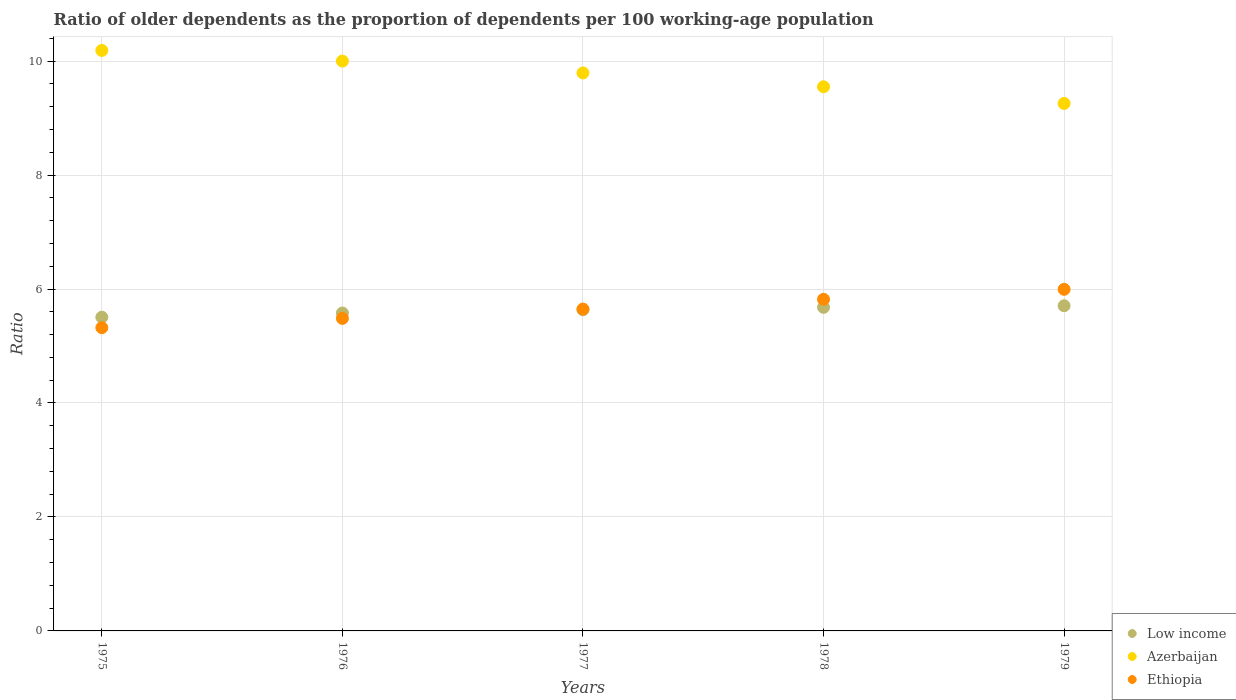How many different coloured dotlines are there?
Keep it short and to the point. 3. What is the age dependency ratio(old) in Azerbaijan in 1978?
Your answer should be very brief. 9.55. Across all years, what is the maximum age dependency ratio(old) in Ethiopia?
Make the answer very short. 5.99. Across all years, what is the minimum age dependency ratio(old) in Azerbaijan?
Keep it short and to the point. 9.26. In which year was the age dependency ratio(old) in Low income maximum?
Keep it short and to the point. 1979. In which year was the age dependency ratio(old) in Ethiopia minimum?
Your response must be concise. 1975. What is the total age dependency ratio(old) in Azerbaijan in the graph?
Make the answer very short. 48.78. What is the difference between the age dependency ratio(old) in Low income in 1975 and that in 1979?
Make the answer very short. -0.2. What is the difference between the age dependency ratio(old) in Ethiopia in 1979 and the age dependency ratio(old) in Azerbaijan in 1978?
Ensure brevity in your answer.  -3.55. What is the average age dependency ratio(old) in Low income per year?
Ensure brevity in your answer.  5.62. In the year 1977, what is the difference between the age dependency ratio(old) in Ethiopia and age dependency ratio(old) in Low income?
Provide a succinct answer. 0.01. In how many years, is the age dependency ratio(old) in Ethiopia greater than 4?
Offer a very short reply. 5. What is the ratio of the age dependency ratio(old) in Ethiopia in 1976 to that in 1979?
Your answer should be compact. 0.91. Is the age dependency ratio(old) in Ethiopia in 1976 less than that in 1979?
Your answer should be compact. Yes. Is the difference between the age dependency ratio(old) in Ethiopia in 1978 and 1979 greater than the difference between the age dependency ratio(old) in Low income in 1978 and 1979?
Provide a succinct answer. No. What is the difference between the highest and the second highest age dependency ratio(old) in Azerbaijan?
Your answer should be very brief. 0.19. What is the difference between the highest and the lowest age dependency ratio(old) in Ethiopia?
Make the answer very short. 0.67. Is the sum of the age dependency ratio(old) in Ethiopia in 1976 and 1978 greater than the maximum age dependency ratio(old) in Azerbaijan across all years?
Provide a succinct answer. Yes. Does the age dependency ratio(old) in Ethiopia monotonically increase over the years?
Ensure brevity in your answer.  Yes. Is the age dependency ratio(old) in Azerbaijan strictly greater than the age dependency ratio(old) in Ethiopia over the years?
Ensure brevity in your answer.  Yes. Is the age dependency ratio(old) in Low income strictly less than the age dependency ratio(old) in Ethiopia over the years?
Your answer should be very brief. No. How many years are there in the graph?
Keep it short and to the point. 5. How many legend labels are there?
Your answer should be very brief. 3. How are the legend labels stacked?
Your answer should be very brief. Vertical. What is the title of the graph?
Offer a terse response. Ratio of older dependents as the proportion of dependents per 100 working-age population. What is the label or title of the X-axis?
Offer a very short reply. Years. What is the label or title of the Y-axis?
Your answer should be very brief. Ratio. What is the Ratio of Low income in 1975?
Make the answer very short. 5.51. What is the Ratio in Azerbaijan in 1975?
Give a very brief answer. 10.19. What is the Ratio in Ethiopia in 1975?
Provide a succinct answer. 5.32. What is the Ratio of Low income in 1976?
Offer a very short reply. 5.58. What is the Ratio in Azerbaijan in 1976?
Your answer should be compact. 10. What is the Ratio in Ethiopia in 1976?
Your response must be concise. 5.48. What is the Ratio of Low income in 1977?
Offer a terse response. 5.64. What is the Ratio in Azerbaijan in 1977?
Your response must be concise. 9.79. What is the Ratio of Ethiopia in 1977?
Your answer should be very brief. 5.65. What is the Ratio of Low income in 1978?
Your response must be concise. 5.68. What is the Ratio in Azerbaijan in 1978?
Make the answer very short. 9.55. What is the Ratio in Ethiopia in 1978?
Keep it short and to the point. 5.82. What is the Ratio in Low income in 1979?
Offer a very short reply. 5.71. What is the Ratio of Azerbaijan in 1979?
Give a very brief answer. 9.26. What is the Ratio of Ethiopia in 1979?
Your answer should be very brief. 5.99. Across all years, what is the maximum Ratio in Low income?
Make the answer very short. 5.71. Across all years, what is the maximum Ratio in Azerbaijan?
Your response must be concise. 10.19. Across all years, what is the maximum Ratio of Ethiopia?
Offer a terse response. 5.99. Across all years, what is the minimum Ratio in Low income?
Your answer should be very brief. 5.51. Across all years, what is the minimum Ratio in Azerbaijan?
Ensure brevity in your answer.  9.26. Across all years, what is the minimum Ratio in Ethiopia?
Your answer should be very brief. 5.32. What is the total Ratio in Low income in the graph?
Give a very brief answer. 28.1. What is the total Ratio of Azerbaijan in the graph?
Provide a short and direct response. 48.78. What is the total Ratio of Ethiopia in the graph?
Your answer should be very brief. 28.27. What is the difference between the Ratio in Low income in 1975 and that in 1976?
Make the answer very short. -0.07. What is the difference between the Ratio in Azerbaijan in 1975 and that in 1976?
Keep it short and to the point. 0.19. What is the difference between the Ratio in Ethiopia in 1975 and that in 1976?
Ensure brevity in your answer.  -0.16. What is the difference between the Ratio in Low income in 1975 and that in 1977?
Make the answer very short. -0.13. What is the difference between the Ratio in Azerbaijan in 1975 and that in 1977?
Make the answer very short. 0.39. What is the difference between the Ratio of Ethiopia in 1975 and that in 1977?
Your answer should be compact. -0.33. What is the difference between the Ratio in Low income in 1975 and that in 1978?
Offer a very short reply. -0.17. What is the difference between the Ratio of Azerbaijan in 1975 and that in 1978?
Keep it short and to the point. 0.64. What is the difference between the Ratio in Ethiopia in 1975 and that in 1978?
Keep it short and to the point. -0.5. What is the difference between the Ratio in Low income in 1975 and that in 1979?
Give a very brief answer. -0.2. What is the difference between the Ratio in Ethiopia in 1975 and that in 1979?
Offer a very short reply. -0.67. What is the difference between the Ratio in Low income in 1976 and that in 1977?
Your answer should be compact. -0.06. What is the difference between the Ratio in Azerbaijan in 1976 and that in 1977?
Offer a very short reply. 0.21. What is the difference between the Ratio of Ethiopia in 1976 and that in 1977?
Ensure brevity in your answer.  -0.16. What is the difference between the Ratio of Low income in 1976 and that in 1978?
Offer a very short reply. -0.1. What is the difference between the Ratio in Azerbaijan in 1976 and that in 1978?
Ensure brevity in your answer.  0.45. What is the difference between the Ratio in Ethiopia in 1976 and that in 1978?
Offer a terse response. -0.34. What is the difference between the Ratio in Low income in 1976 and that in 1979?
Your response must be concise. -0.13. What is the difference between the Ratio of Azerbaijan in 1976 and that in 1979?
Provide a succinct answer. 0.74. What is the difference between the Ratio of Ethiopia in 1976 and that in 1979?
Provide a short and direct response. -0.51. What is the difference between the Ratio in Low income in 1977 and that in 1978?
Offer a terse response. -0.04. What is the difference between the Ratio of Azerbaijan in 1977 and that in 1978?
Make the answer very short. 0.24. What is the difference between the Ratio of Ethiopia in 1977 and that in 1978?
Offer a terse response. -0.17. What is the difference between the Ratio in Low income in 1977 and that in 1979?
Provide a succinct answer. -0.07. What is the difference between the Ratio in Azerbaijan in 1977 and that in 1979?
Your answer should be compact. 0.54. What is the difference between the Ratio of Ethiopia in 1977 and that in 1979?
Make the answer very short. -0.35. What is the difference between the Ratio of Low income in 1978 and that in 1979?
Provide a short and direct response. -0.03. What is the difference between the Ratio of Azerbaijan in 1978 and that in 1979?
Your response must be concise. 0.29. What is the difference between the Ratio of Ethiopia in 1978 and that in 1979?
Give a very brief answer. -0.17. What is the difference between the Ratio in Low income in 1975 and the Ratio in Azerbaijan in 1976?
Offer a very short reply. -4.49. What is the difference between the Ratio of Low income in 1975 and the Ratio of Ethiopia in 1976?
Ensure brevity in your answer.  0.02. What is the difference between the Ratio of Azerbaijan in 1975 and the Ratio of Ethiopia in 1976?
Provide a succinct answer. 4.7. What is the difference between the Ratio of Low income in 1975 and the Ratio of Azerbaijan in 1977?
Offer a terse response. -4.29. What is the difference between the Ratio of Low income in 1975 and the Ratio of Ethiopia in 1977?
Provide a short and direct response. -0.14. What is the difference between the Ratio in Azerbaijan in 1975 and the Ratio in Ethiopia in 1977?
Ensure brevity in your answer.  4.54. What is the difference between the Ratio of Low income in 1975 and the Ratio of Azerbaijan in 1978?
Offer a terse response. -4.04. What is the difference between the Ratio in Low income in 1975 and the Ratio in Ethiopia in 1978?
Give a very brief answer. -0.31. What is the difference between the Ratio of Azerbaijan in 1975 and the Ratio of Ethiopia in 1978?
Make the answer very short. 4.37. What is the difference between the Ratio in Low income in 1975 and the Ratio in Azerbaijan in 1979?
Ensure brevity in your answer.  -3.75. What is the difference between the Ratio in Low income in 1975 and the Ratio in Ethiopia in 1979?
Your answer should be very brief. -0.49. What is the difference between the Ratio in Azerbaijan in 1975 and the Ratio in Ethiopia in 1979?
Provide a short and direct response. 4.19. What is the difference between the Ratio in Low income in 1976 and the Ratio in Azerbaijan in 1977?
Make the answer very short. -4.21. What is the difference between the Ratio in Low income in 1976 and the Ratio in Ethiopia in 1977?
Keep it short and to the point. -0.07. What is the difference between the Ratio of Azerbaijan in 1976 and the Ratio of Ethiopia in 1977?
Keep it short and to the point. 4.35. What is the difference between the Ratio of Low income in 1976 and the Ratio of Azerbaijan in 1978?
Ensure brevity in your answer.  -3.97. What is the difference between the Ratio in Low income in 1976 and the Ratio in Ethiopia in 1978?
Your answer should be compact. -0.24. What is the difference between the Ratio of Azerbaijan in 1976 and the Ratio of Ethiopia in 1978?
Your answer should be very brief. 4.18. What is the difference between the Ratio in Low income in 1976 and the Ratio in Azerbaijan in 1979?
Ensure brevity in your answer.  -3.68. What is the difference between the Ratio in Low income in 1976 and the Ratio in Ethiopia in 1979?
Offer a very short reply. -0.42. What is the difference between the Ratio of Azerbaijan in 1976 and the Ratio of Ethiopia in 1979?
Your answer should be compact. 4.01. What is the difference between the Ratio of Low income in 1977 and the Ratio of Azerbaijan in 1978?
Your answer should be compact. -3.91. What is the difference between the Ratio in Low income in 1977 and the Ratio in Ethiopia in 1978?
Your answer should be compact. -0.18. What is the difference between the Ratio of Azerbaijan in 1977 and the Ratio of Ethiopia in 1978?
Provide a succinct answer. 3.97. What is the difference between the Ratio of Low income in 1977 and the Ratio of Azerbaijan in 1979?
Provide a short and direct response. -3.62. What is the difference between the Ratio in Low income in 1977 and the Ratio in Ethiopia in 1979?
Provide a succinct answer. -0.36. What is the difference between the Ratio in Azerbaijan in 1977 and the Ratio in Ethiopia in 1979?
Ensure brevity in your answer.  3.8. What is the difference between the Ratio in Low income in 1978 and the Ratio in Azerbaijan in 1979?
Offer a terse response. -3.58. What is the difference between the Ratio in Low income in 1978 and the Ratio in Ethiopia in 1979?
Offer a terse response. -0.32. What is the difference between the Ratio of Azerbaijan in 1978 and the Ratio of Ethiopia in 1979?
Offer a very short reply. 3.55. What is the average Ratio in Low income per year?
Make the answer very short. 5.62. What is the average Ratio in Azerbaijan per year?
Ensure brevity in your answer.  9.76. What is the average Ratio in Ethiopia per year?
Ensure brevity in your answer.  5.65. In the year 1975, what is the difference between the Ratio in Low income and Ratio in Azerbaijan?
Offer a very short reply. -4.68. In the year 1975, what is the difference between the Ratio in Low income and Ratio in Ethiopia?
Provide a short and direct response. 0.18. In the year 1975, what is the difference between the Ratio of Azerbaijan and Ratio of Ethiopia?
Provide a short and direct response. 4.87. In the year 1976, what is the difference between the Ratio in Low income and Ratio in Azerbaijan?
Keep it short and to the point. -4.42. In the year 1976, what is the difference between the Ratio in Low income and Ratio in Ethiopia?
Offer a terse response. 0.09. In the year 1976, what is the difference between the Ratio in Azerbaijan and Ratio in Ethiopia?
Make the answer very short. 4.52. In the year 1977, what is the difference between the Ratio of Low income and Ratio of Azerbaijan?
Give a very brief answer. -4.16. In the year 1977, what is the difference between the Ratio of Low income and Ratio of Ethiopia?
Keep it short and to the point. -0.01. In the year 1977, what is the difference between the Ratio in Azerbaijan and Ratio in Ethiopia?
Your response must be concise. 4.14. In the year 1978, what is the difference between the Ratio in Low income and Ratio in Azerbaijan?
Keep it short and to the point. -3.87. In the year 1978, what is the difference between the Ratio in Low income and Ratio in Ethiopia?
Provide a short and direct response. -0.14. In the year 1978, what is the difference between the Ratio in Azerbaijan and Ratio in Ethiopia?
Provide a succinct answer. 3.73. In the year 1979, what is the difference between the Ratio of Low income and Ratio of Azerbaijan?
Provide a short and direct response. -3.55. In the year 1979, what is the difference between the Ratio of Low income and Ratio of Ethiopia?
Give a very brief answer. -0.29. In the year 1979, what is the difference between the Ratio in Azerbaijan and Ratio in Ethiopia?
Your answer should be compact. 3.26. What is the ratio of the Ratio in Low income in 1975 to that in 1976?
Offer a very short reply. 0.99. What is the ratio of the Ratio of Azerbaijan in 1975 to that in 1976?
Keep it short and to the point. 1.02. What is the ratio of the Ratio in Ethiopia in 1975 to that in 1976?
Offer a very short reply. 0.97. What is the ratio of the Ratio in Low income in 1975 to that in 1977?
Provide a succinct answer. 0.98. What is the ratio of the Ratio of Azerbaijan in 1975 to that in 1977?
Make the answer very short. 1.04. What is the ratio of the Ratio in Ethiopia in 1975 to that in 1977?
Give a very brief answer. 0.94. What is the ratio of the Ratio in Low income in 1975 to that in 1978?
Provide a short and direct response. 0.97. What is the ratio of the Ratio of Azerbaijan in 1975 to that in 1978?
Offer a very short reply. 1.07. What is the ratio of the Ratio in Ethiopia in 1975 to that in 1978?
Offer a very short reply. 0.91. What is the ratio of the Ratio of Low income in 1975 to that in 1979?
Ensure brevity in your answer.  0.96. What is the ratio of the Ratio of Azerbaijan in 1975 to that in 1979?
Offer a terse response. 1.1. What is the ratio of the Ratio in Ethiopia in 1975 to that in 1979?
Offer a terse response. 0.89. What is the ratio of the Ratio in Azerbaijan in 1976 to that in 1977?
Your answer should be compact. 1.02. What is the ratio of the Ratio of Low income in 1976 to that in 1978?
Ensure brevity in your answer.  0.98. What is the ratio of the Ratio in Azerbaijan in 1976 to that in 1978?
Make the answer very short. 1.05. What is the ratio of the Ratio in Ethiopia in 1976 to that in 1978?
Make the answer very short. 0.94. What is the ratio of the Ratio of Low income in 1976 to that in 1979?
Ensure brevity in your answer.  0.98. What is the ratio of the Ratio in Azerbaijan in 1976 to that in 1979?
Provide a short and direct response. 1.08. What is the ratio of the Ratio in Ethiopia in 1976 to that in 1979?
Make the answer very short. 0.91. What is the ratio of the Ratio of Low income in 1977 to that in 1978?
Your answer should be very brief. 0.99. What is the ratio of the Ratio of Azerbaijan in 1977 to that in 1978?
Your response must be concise. 1.03. What is the ratio of the Ratio of Ethiopia in 1977 to that in 1978?
Your answer should be very brief. 0.97. What is the ratio of the Ratio in Azerbaijan in 1977 to that in 1979?
Your answer should be compact. 1.06. What is the ratio of the Ratio of Ethiopia in 1977 to that in 1979?
Offer a terse response. 0.94. What is the ratio of the Ratio of Low income in 1978 to that in 1979?
Offer a terse response. 1. What is the ratio of the Ratio of Azerbaijan in 1978 to that in 1979?
Give a very brief answer. 1.03. What is the ratio of the Ratio in Ethiopia in 1978 to that in 1979?
Your answer should be compact. 0.97. What is the difference between the highest and the second highest Ratio of Low income?
Ensure brevity in your answer.  0.03. What is the difference between the highest and the second highest Ratio in Azerbaijan?
Offer a very short reply. 0.19. What is the difference between the highest and the second highest Ratio of Ethiopia?
Give a very brief answer. 0.17. What is the difference between the highest and the lowest Ratio in Low income?
Your response must be concise. 0.2. What is the difference between the highest and the lowest Ratio in Ethiopia?
Ensure brevity in your answer.  0.67. 